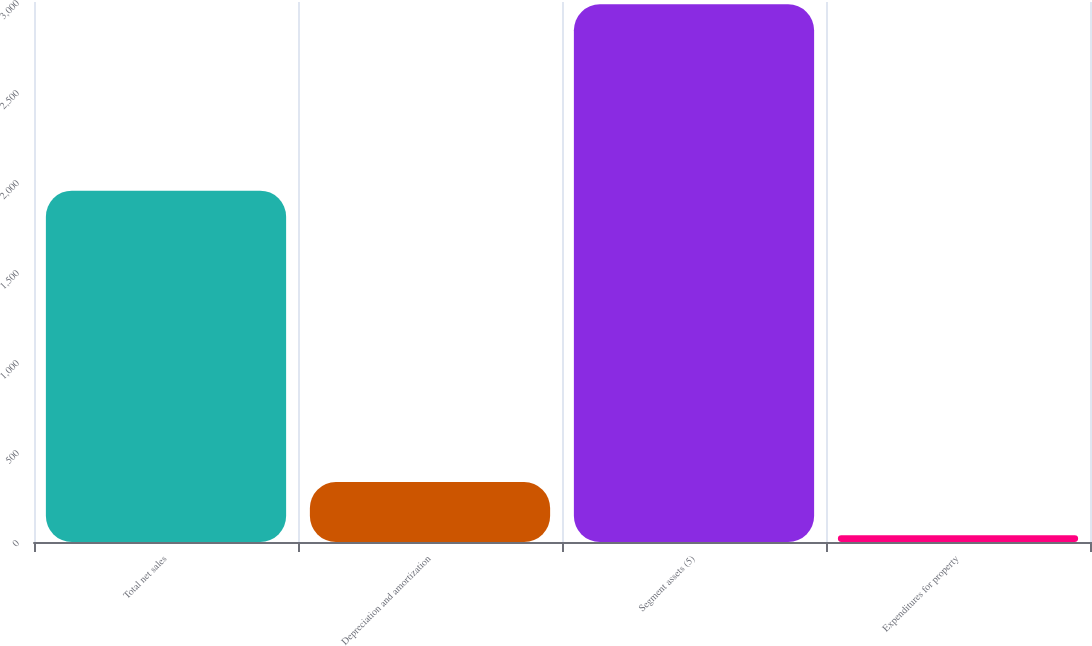Convert chart. <chart><loc_0><loc_0><loc_500><loc_500><bar_chart><fcel>Total net sales<fcel>Depreciation and amortization<fcel>Segment assets (5)<fcel>Expenditures for property<nl><fcel>1952<fcel>332.9<fcel>2987<fcel>38<nl></chart> 